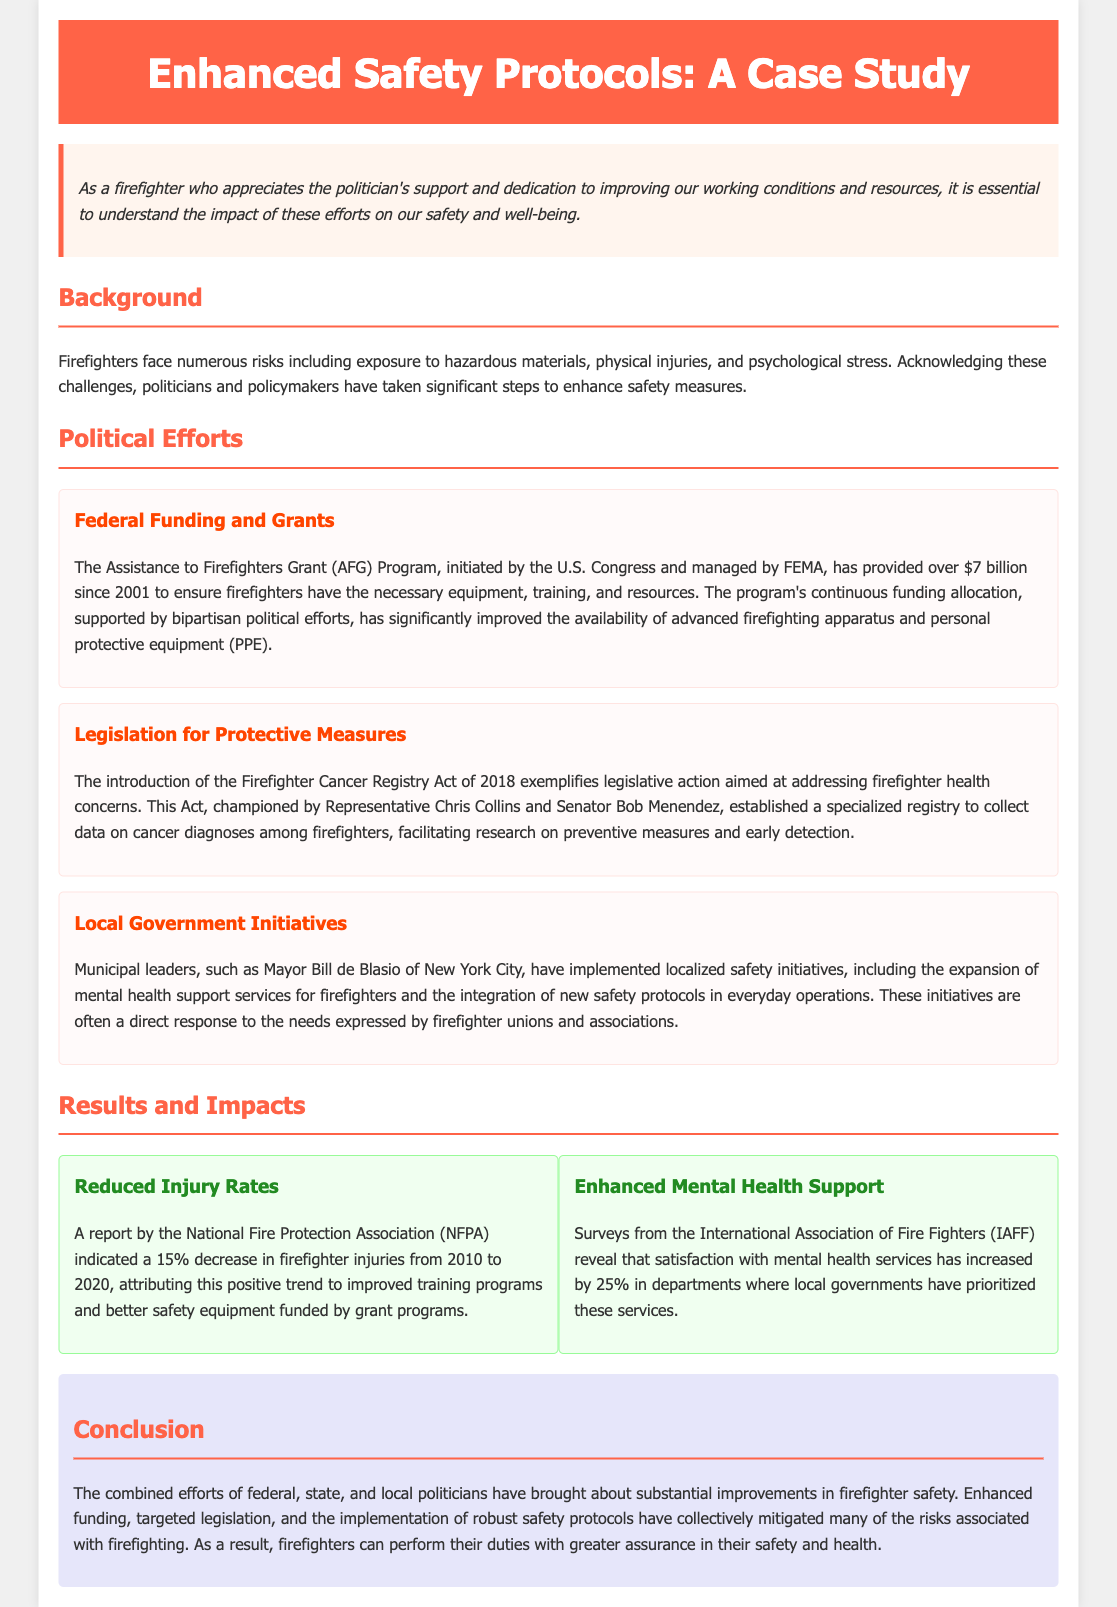What is the total funding provided by the Assistance to Firefighters Grant Program since 2001? The total funding provided by the AFG Program is mentioned as over $7 billion since 2001.
Answer: over $7 billion Which Act was introduced to address firefighter health concerns related to cancer? The document mentions the introduction of the Firefighter Cancer Registry Act of 2018 to address cancer health concerns for firefighters.
Answer: Firefighter Cancer Registry Act of 2018 What percentage decrease in firefighter injuries was reported from 2010 to 2020? The document states that there was a 15% decrease in firefighter injuries between 2010 and 2020.
Answer: 15% Who championed the Firefighter Cancer Registry Act? The document names Representative Chris Collins and Senator Bob Menendez as champions of the Firefighter Cancer Registry Act.
Answer: Representative Chris Collins and Senator Bob Menendez What local government initiative did Mayor Bill de Blasio implement? The document highlights that Mayor Bill de Blasio implemented localized safety initiatives, including mental health support services for firefighters.
Answer: expansion of mental health support services How much has satisfaction with mental health services increased according to surveys from the IAFF? According to the document, satisfaction with mental health services has increased by 25% in departments prioritizing these services.
Answer: 25% What organization reported the decrease in firefighter injuries? The report on the decrease in injury rates was conducted by the National Fire Protection Association (NFPA).
Answer: National Fire Protection Association (NFPA) What is the main conclusion regarding firefighter safety improvements? The conclusion states that combined efforts of politicians have brought about substantial improvements in firefighter safety.
Answer: substantial improvements in firefighter safety What is the purpose of the Assistance to Firefighters Grant Program? The AFG Program aims to ensure firefighters have the necessary equipment, training, and resources.
Answer: necessary equipment, training, and resources 